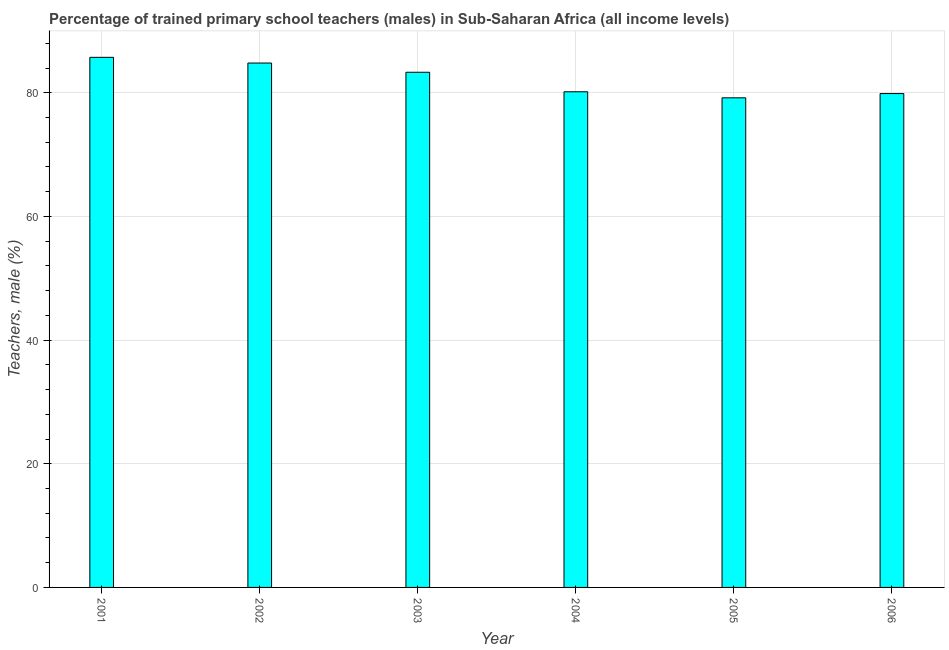What is the title of the graph?
Make the answer very short. Percentage of trained primary school teachers (males) in Sub-Saharan Africa (all income levels). What is the label or title of the Y-axis?
Your answer should be compact. Teachers, male (%). What is the percentage of trained male teachers in 2003?
Offer a very short reply. 83.32. Across all years, what is the maximum percentage of trained male teachers?
Your response must be concise. 85.73. Across all years, what is the minimum percentage of trained male teachers?
Keep it short and to the point. 79.19. In which year was the percentage of trained male teachers maximum?
Your response must be concise. 2001. In which year was the percentage of trained male teachers minimum?
Your answer should be compact. 2005. What is the sum of the percentage of trained male teachers?
Provide a succinct answer. 493.09. What is the difference between the percentage of trained male teachers in 2002 and 2006?
Give a very brief answer. 4.94. What is the average percentage of trained male teachers per year?
Provide a short and direct response. 82.18. What is the median percentage of trained male teachers?
Your response must be concise. 81.74. In how many years, is the percentage of trained male teachers greater than 24 %?
Offer a very short reply. 6. Do a majority of the years between 2002 and 2001 (inclusive) have percentage of trained male teachers greater than 36 %?
Your response must be concise. No. What is the ratio of the percentage of trained male teachers in 2003 to that in 2005?
Make the answer very short. 1.05. Is the percentage of trained male teachers in 2001 less than that in 2004?
Make the answer very short. No. What is the difference between the highest and the second highest percentage of trained male teachers?
Offer a very short reply. 0.92. Is the sum of the percentage of trained male teachers in 2004 and 2006 greater than the maximum percentage of trained male teachers across all years?
Offer a terse response. Yes. What is the difference between the highest and the lowest percentage of trained male teachers?
Keep it short and to the point. 6.55. How many bars are there?
Your answer should be very brief. 6. Are all the bars in the graph horizontal?
Make the answer very short. No. How many years are there in the graph?
Give a very brief answer. 6. What is the difference between two consecutive major ticks on the Y-axis?
Provide a succinct answer. 20. What is the Teachers, male (%) in 2001?
Offer a terse response. 85.73. What is the Teachers, male (%) of 2002?
Ensure brevity in your answer.  84.81. What is the Teachers, male (%) of 2003?
Your answer should be very brief. 83.32. What is the Teachers, male (%) in 2004?
Your answer should be very brief. 80.16. What is the Teachers, male (%) in 2005?
Give a very brief answer. 79.19. What is the Teachers, male (%) of 2006?
Your answer should be very brief. 79.87. What is the difference between the Teachers, male (%) in 2001 and 2002?
Ensure brevity in your answer.  0.92. What is the difference between the Teachers, male (%) in 2001 and 2003?
Provide a short and direct response. 2.41. What is the difference between the Teachers, male (%) in 2001 and 2004?
Your answer should be compact. 5.57. What is the difference between the Teachers, male (%) in 2001 and 2005?
Provide a short and direct response. 6.55. What is the difference between the Teachers, male (%) in 2001 and 2006?
Ensure brevity in your answer.  5.86. What is the difference between the Teachers, male (%) in 2002 and 2003?
Make the answer very short. 1.49. What is the difference between the Teachers, male (%) in 2002 and 2004?
Offer a very short reply. 4.65. What is the difference between the Teachers, male (%) in 2002 and 2005?
Ensure brevity in your answer.  5.62. What is the difference between the Teachers, male (%) in 2002 and 2006?
Keep it short and to the point. 4.94. What is the difference between the Teachers, male (%) in 2003 and 2004?
Ensure brevity in your answer.  3.16. What is the difference between the Teachers, male (%) in 2003 and 2005?
Offer a terse response. 4.13. What is the difference between the Teachers, male (%) in 2003 and 2006?
Your answer should be compact. 3.45. What is the difference between the Teachers, male (%) in 2004 and 2005?
Make the answer very short. 0.98. What is the difference between the Teachers, male (%) in 2004 and 2006?
Provide a short and direct response. 0.29. What is the difference between the Teachers, male (%) in 2005 and 2006?
Provide a succinct answer. -0.69. What is the ratio of the Teachers, male (%) in 2001 to that in 2004?
Offer a terse response. 1.07. What is the ratio of the Teachers, male (%) in 2001 to that in 2005?
Ensure brevity in your answer.  1.08. What is the ratio of the Teachers, male (%) in 2001 to that in 2006?
Provide a short and direct response. 1.07. What is the ratio of the Teachers, male (%) in 2002 to that in 2004?
Provide a short and direct response. 1.06. What is the ratio of the Teachers, male (%) in 2002 to that in 2005?
Make the answer very short. 1.07. What is the ratio of the Teachers, male (%) in 2002 to that in 2006?
Ensure brevity in your answer.  1.06. What is the ratio of the Teachers, male (%) in 2003 to that in 2004?
Give a very brief answer. 1.04. What is the ratio of the Teachers, male (%) in 2003 to that in 2005?
Give a very brief answer. 1.05. What is the ratio of the Teachers, male (%) in 2003 to that in 2006?
Offer a very short reply. 1.04. What is the ratio of the Teachers, male (%) in 2004 to that in 2006?
Give a very brief answer. 1. What is the ratio of the Teachers, male (%) in 2005 to that in 2006?
Your response must be concise. 0.99. 